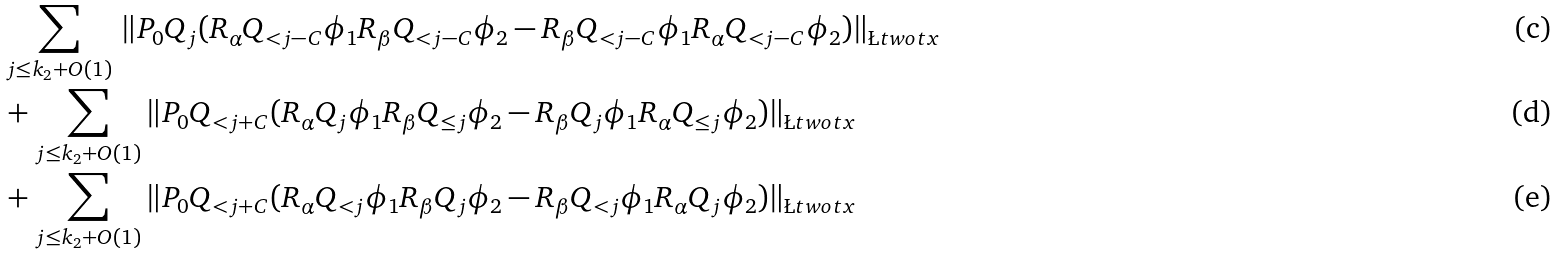<formula> <loc_0><loc_0><loc_500><loc_500>& \sum _ { j \leq k _ { 2 } + O ( 1 ) } \, \| P _ { 0 } Q _ { j } ( R _ { \alpha } Q _ { < j - C } \phi _ { 1 } R _ { \beta } Q _ { < j - C } \phi _ { 2 } - R _ { \beta } Q _ { < j - C } \phi _ { 1 } R _ { \alpha } Q _ { < j - C } \phi _ { 2 } ) \| _ { \L t w o t x } \\ & + \sum _ { j \leq k _ { 2 } + O ( 1 ) } \| P _ { 0 } Q _ { < j + C } ( R _ { \alpha } Q _ { j } \phi _ { 1 } R _ { \beta } Q _ { \leq j } \phi _ { 2 } - R _ { \beta } Q _ { j } \phi _ { 1 } R _ { \alpha } Q _ { \leq j } \phi _ { 2 } ) \| _ { \L t w o t x } \\ & + \sum _ { j \leq k _ { 2 } + O ( 1 ) } \| P _ { 0 } Q _ { < j + C } ( R _ { \alpha } Q _ { < j } \phi _ { 1 } R _ { \beta } Q _ { j } \phi _ { 2 } - R _ { \beta } Q _ { < j } \phi _ { 1 } R _ { \alpha } Q _ { j } \phi _ { 2 } ) \| _ { \L t w o t x }</formula> 